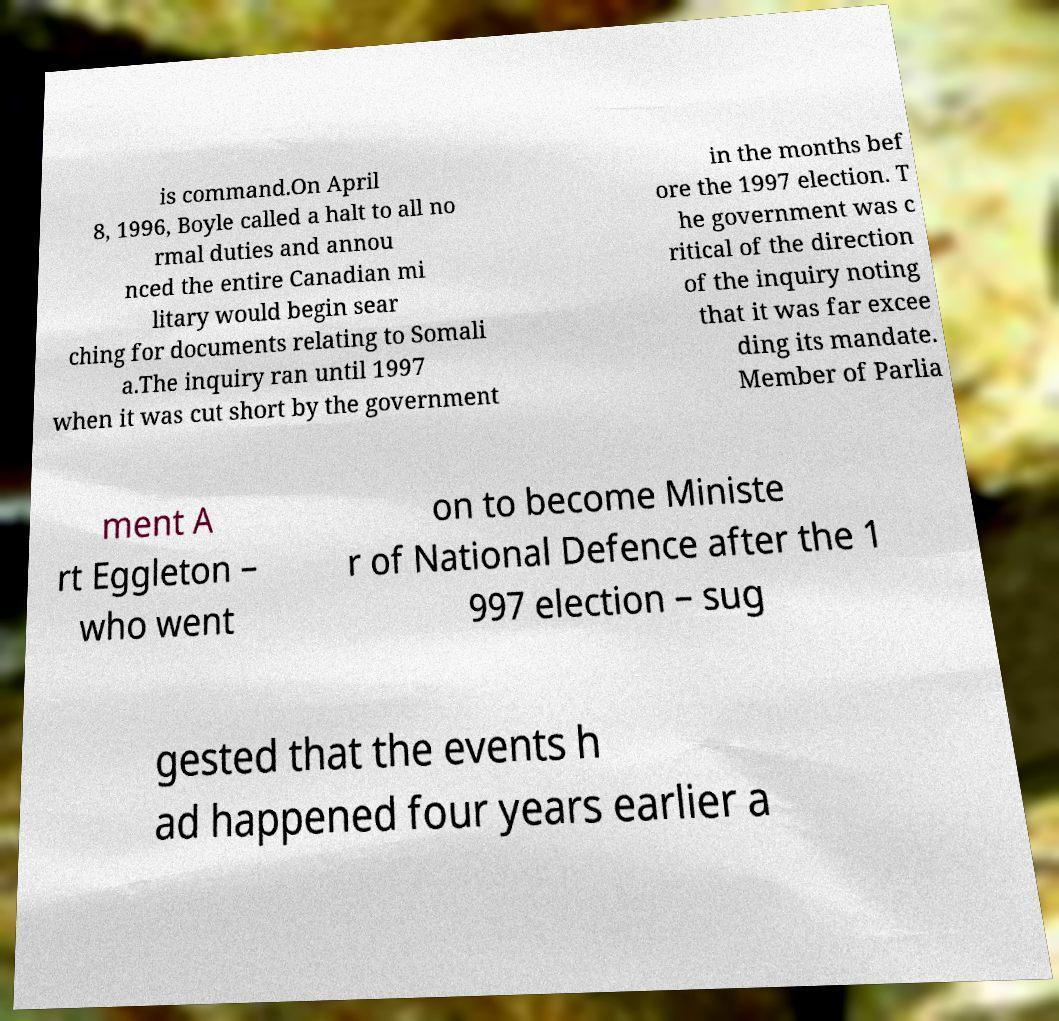Can you read and provide the text displayed in the image?This photo seems to have some interesting text. Can you extract and type it out for me? is command.On April 8, 1996, Boyle called a halt to all no rmal duties and annou nced the entire Canadian mi litary would begin sear ching for documents relating to Somali a.The inquiry ran until 1997 when it was cut short by the government in the months bef ore the 1997 election. T he government was c ritical of the direction of the inquiry noting that it was far excee ding its mandate. Member of Parlia ment A rt Eggleton – who went on to become Ministe r of National Defence after the 1 997 election – sug gested that the events h ad happened four years earlier a 